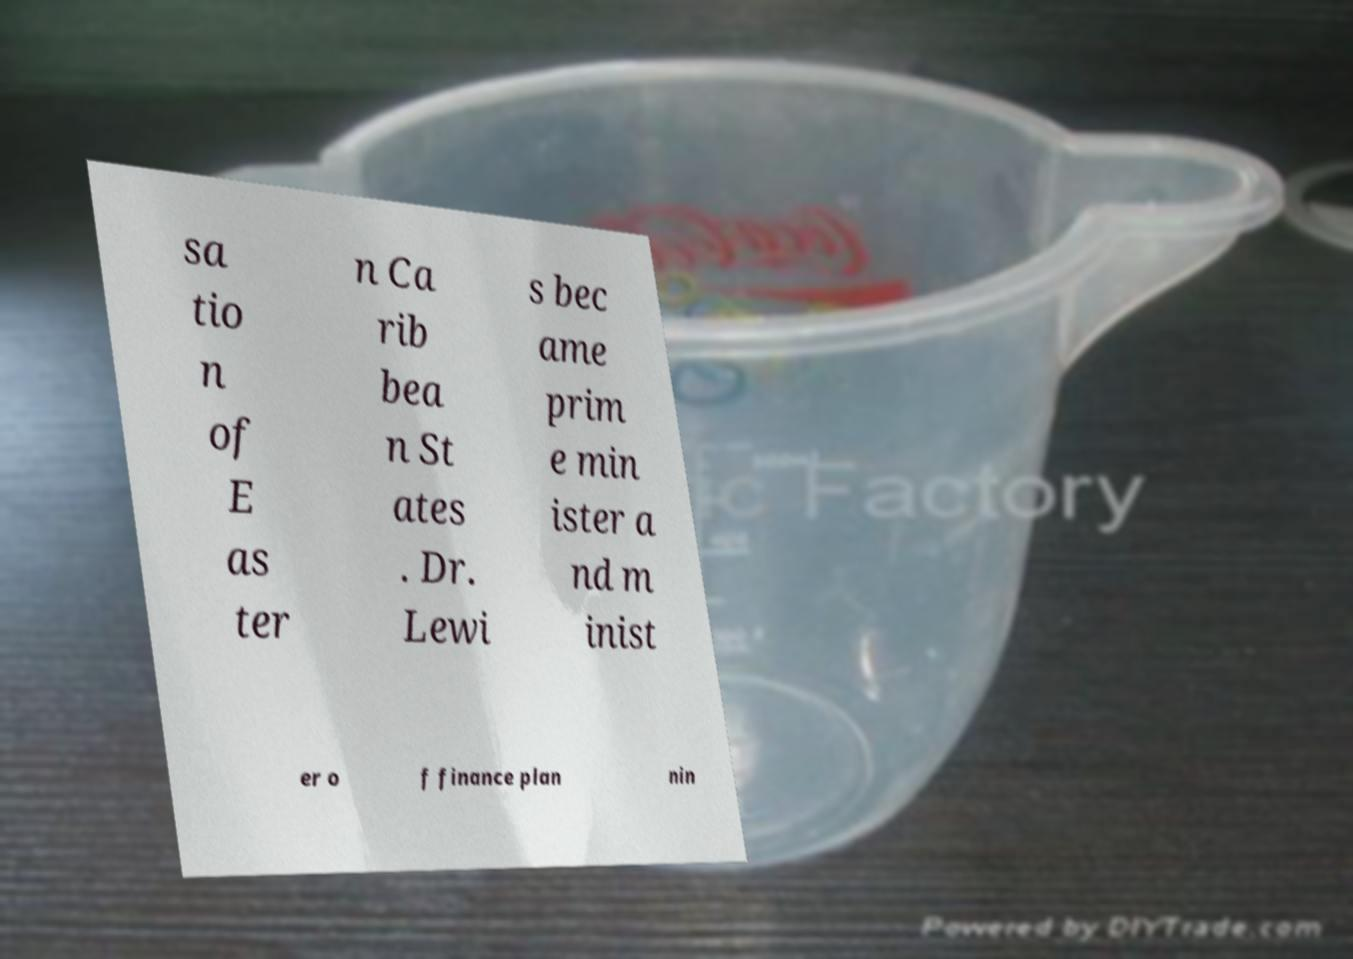I need the written content from this picture converted into text. Can you do that? sa tio n of E as ter n Ca rib bea n St ates . Dr. Lewi s bec ame prim e min ister a nd m inist er o f finance plan nin 